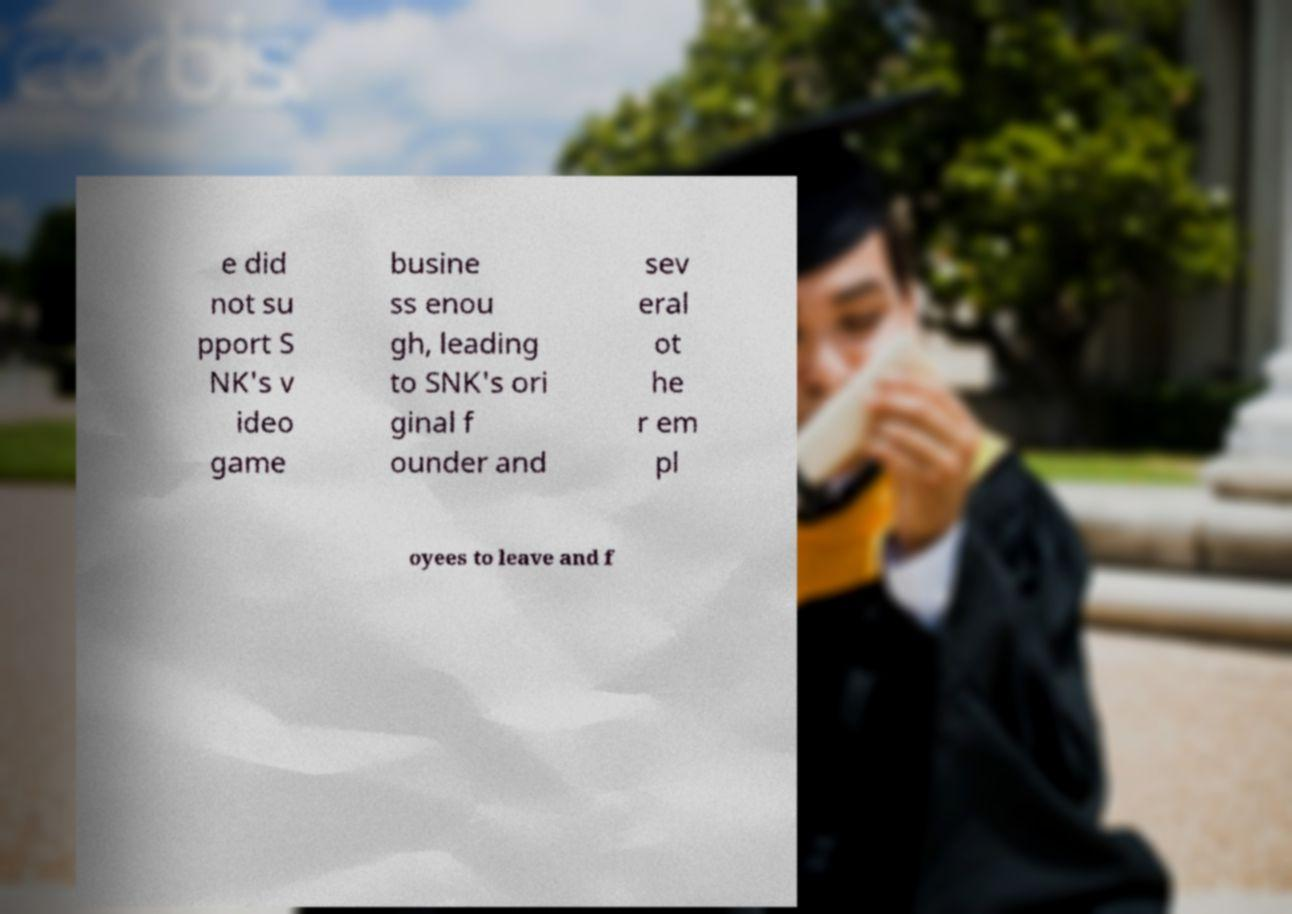Could you extract and type out the text from this image? e did not su pport S NK's v ideo game busine ss enou gh, leading to SNK's ori ginal f ounder and sev eral ot he r em pl oyees to leave and f 